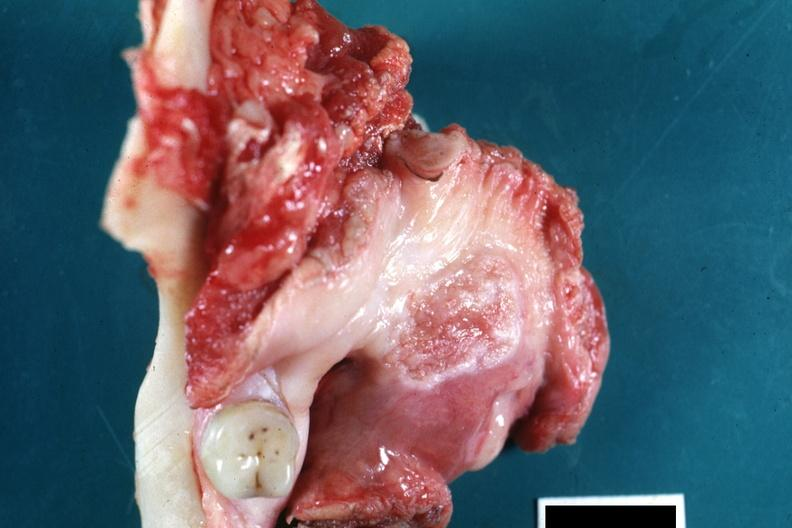s squamous cell carcinoma present?
Answer the question using a single word or phrase. Yes 